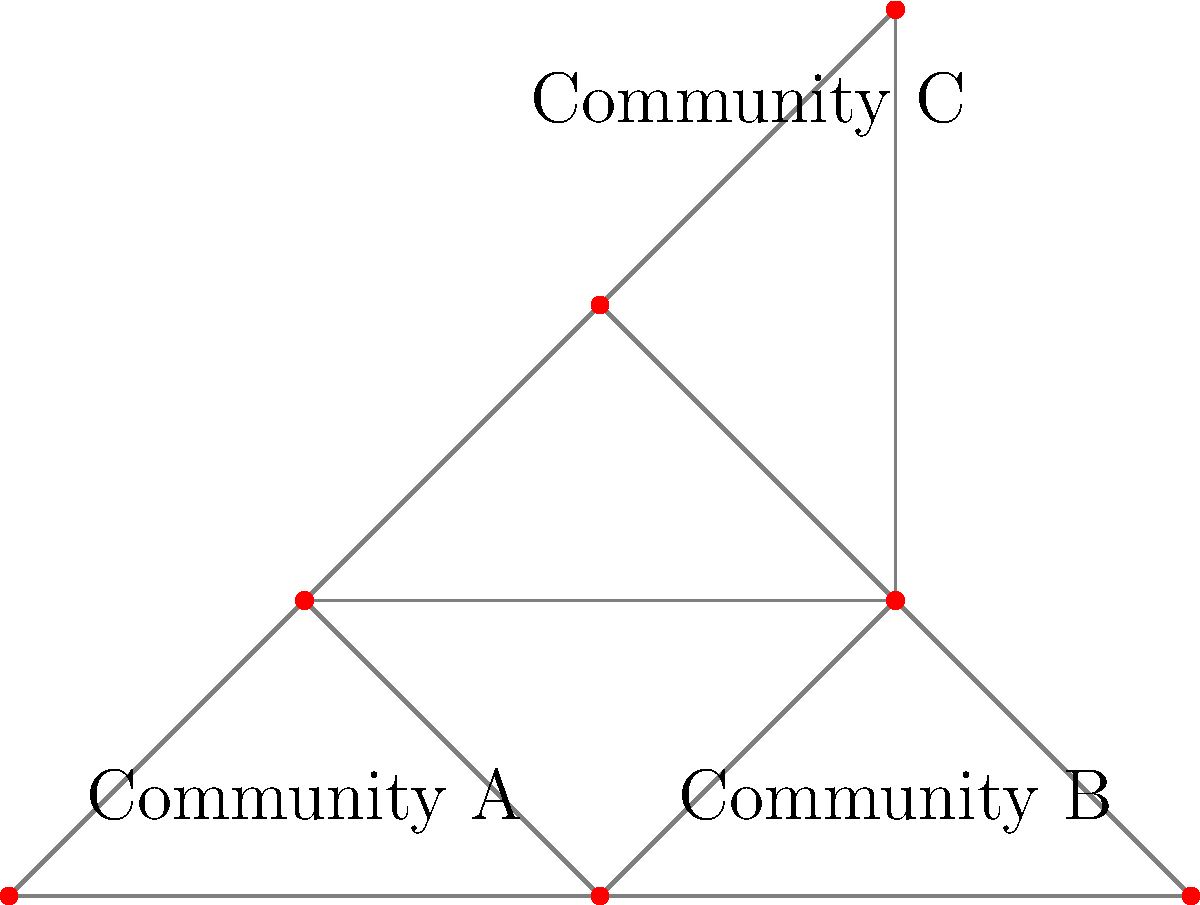In the graph representing grassroots organizing networks, how many communities can be identified using community detection algorithms, and what implications does this have for building solidarity across different activist groups? To answer this question, we need to analyze the graph structure:

1. Observe the graph: The graph shows nodes (representing individuals or groups) connected by edges (representing relationships or interactions).

2. Identify communities:
   a) Community A: Nodes at (0,0), (1,1), and (2,0) form a tightly connected group.
   b) Community B: Nodes at (2,0), (3,1), and (4,0) form another closely connected group.
   c) Community C: Nodes at (2,2), (3,3), and (3,1) form a third distinct group.

3. Count communities: We can identify 3 distinct communities.

4. Analyze implications:
   a) The presence of multiple communities suggests diverse activist groups with different focuses or geographical locations.
   b) Overlapping nodes (e.g., at (2,0) and (3,1)) represent potential bridge-builders between communities.
   c) These bridge nodes are crucial for building solidarity and coordinating actions across different groups.
   d) As a leftist radio host, emphasizing the importance of these connecting individuals or groups can help promote unity and collective action.

5. Strategy for increasing platform popularity:
   a) Highlight the interconnectedness of different activist communities.
   b) Invite representatives from each community to discuss their specific concerns and shared goals.
   c) Use the platform to facilitate discussions on how to strengthen connections between communities.

The community structure revealed by this analysis provides valuable insights for organizing and promoting solidarity among diverse activist groups.
Answer: 3 communities; implications: diverse activist groups, potential for bridge-building and increased solidarity through interconnected networks. 